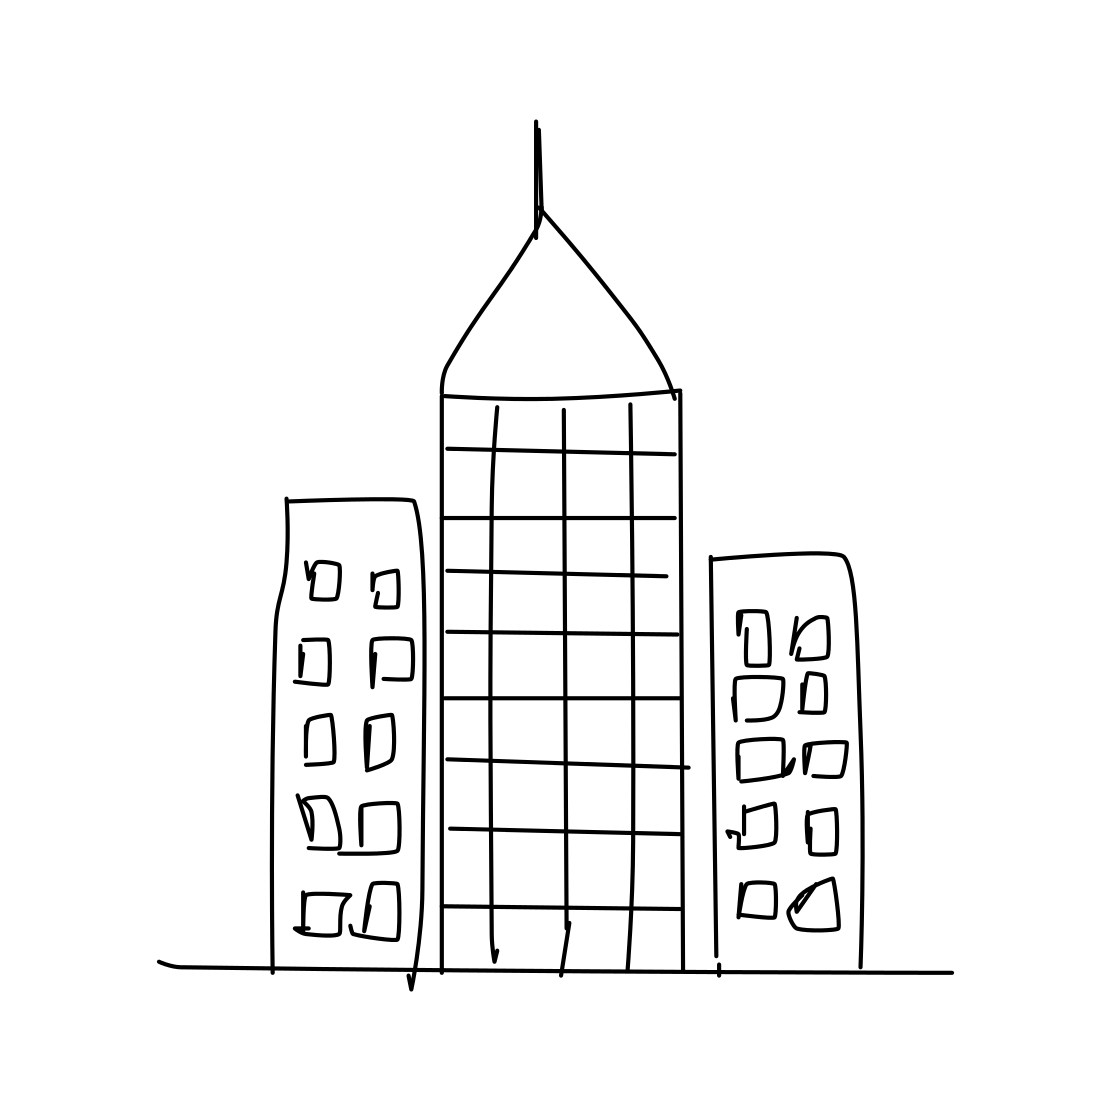Imagine this sketch comes to life. What kind of atmosphere would this city have? If this sketch were to come to life, the city could have a modern, perhaps stark atmosphere with the simplicity of the drawing translated into a clean, uncluttered urban environment. The dominance of the central skyscraper might give it a bustling commercial hub feeling with a mix of energy and order. 